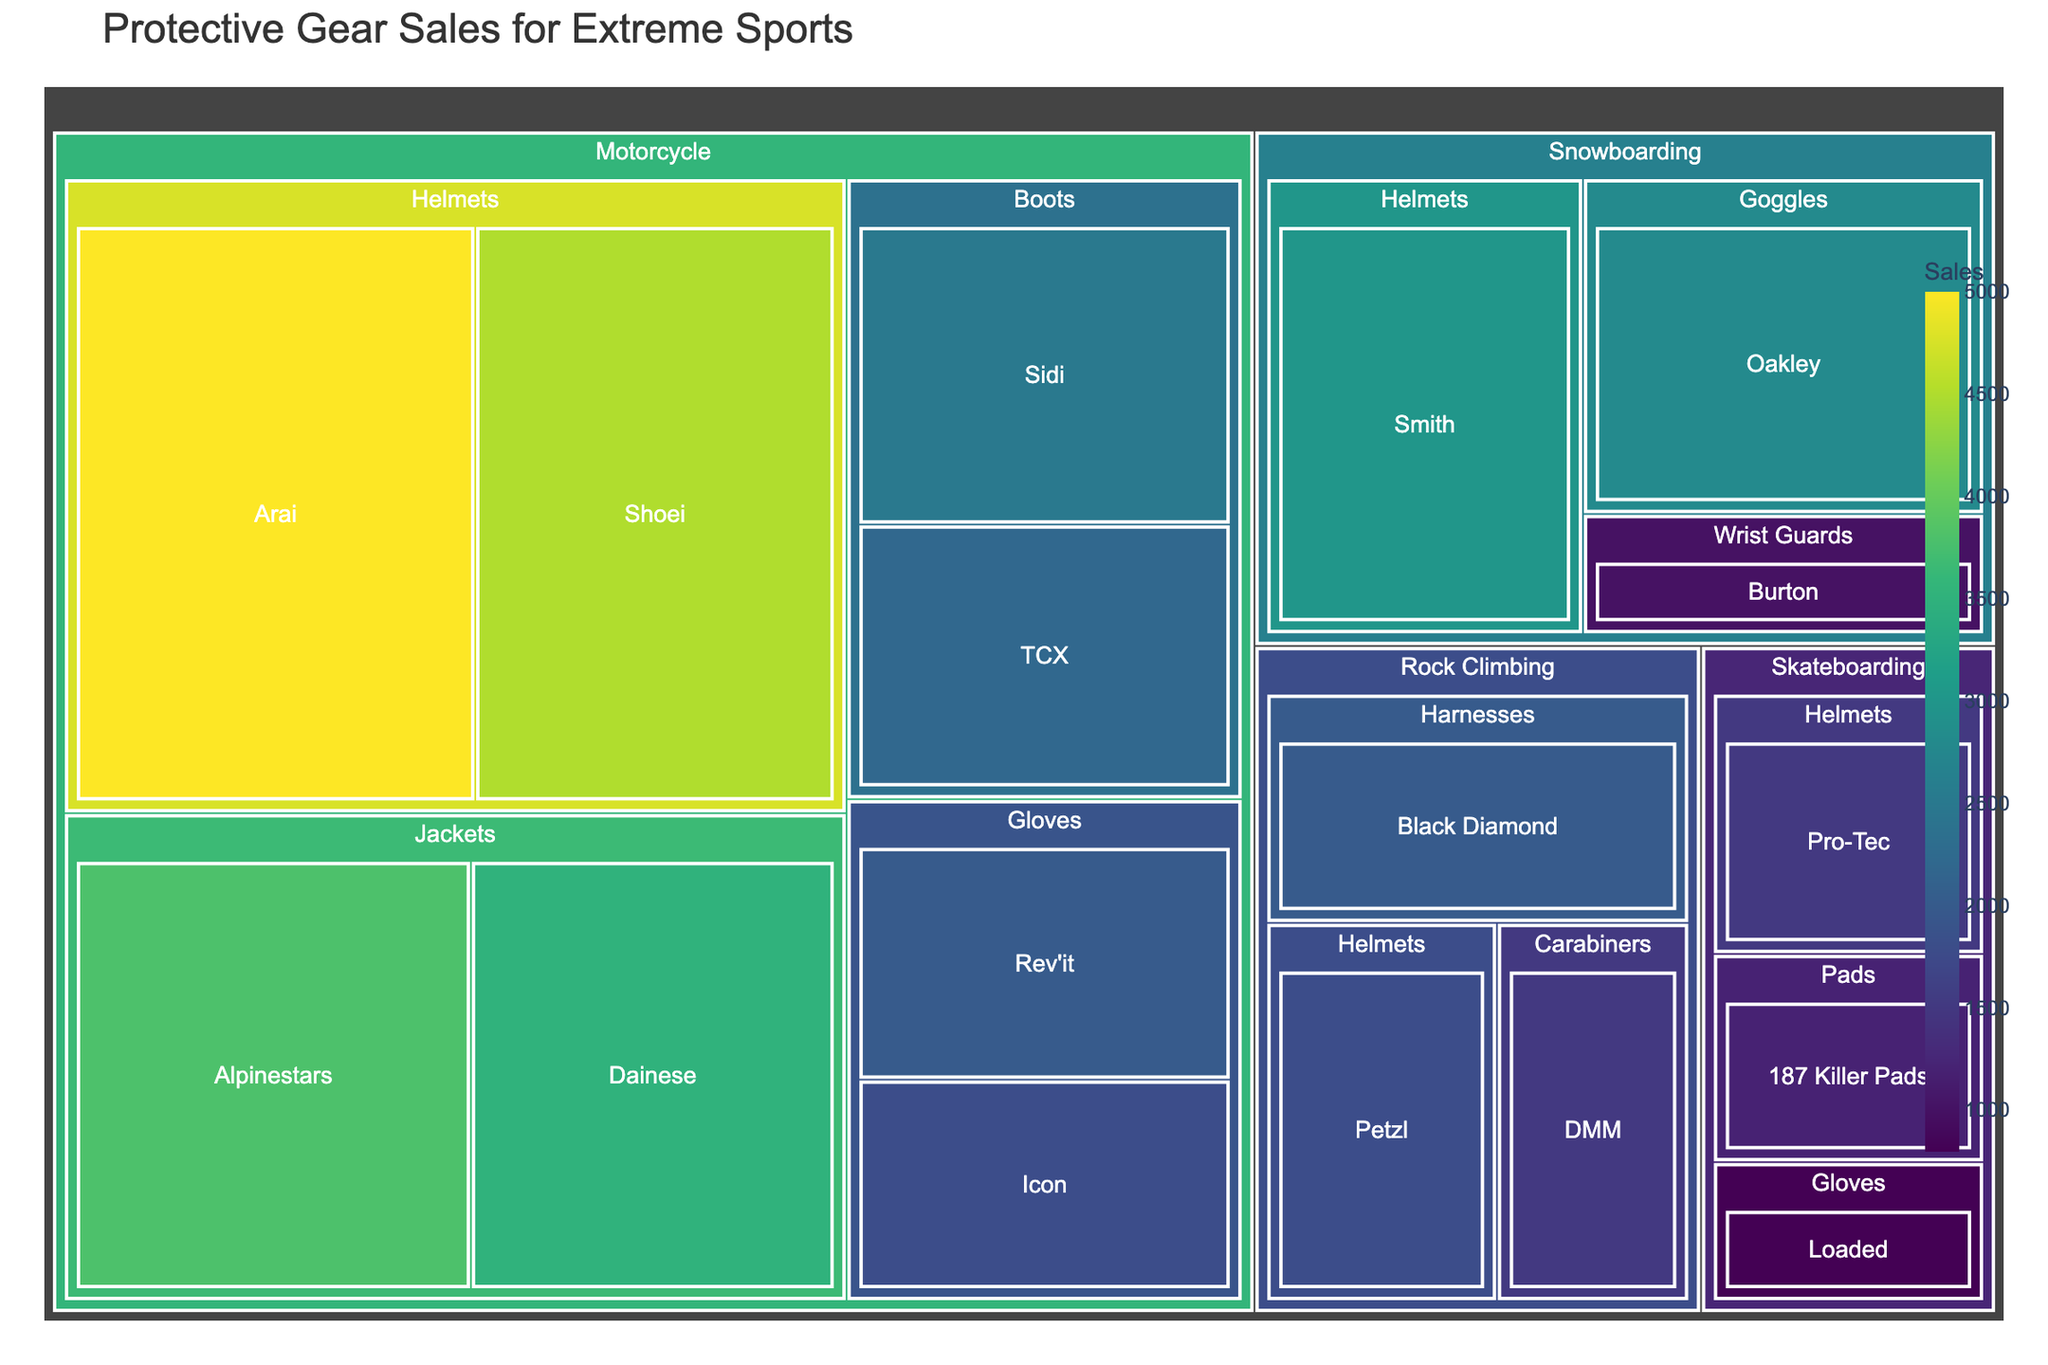What's the title of the treemap figure? The title is usually located at the top of the figure. In this case, it reads 'Protective Gear Sales for Extreme Sports'
Answer: Protective Gear Sales for Extreme Sports Which category has the highest total sales? The treemap visualizes sales by the size of the rectangles. The largest area indicates the category with the highest sales. Motorcycle has the largest area.
Answer: Motorcycle What are the total sales for all Helmet brands combined under the Motorcycle category? Add the sales from Arai and Shoei under the Motorcycle category: 5000 (Arai) + 4500 (Shoei) = 9500
Answer: 9500 Which brand has higher sales, Smith or Oakley? Compare the sales figures for Smith and Oakley. Smith has 3000 and Oakley has 2800. Smith has higher sales.
Answer: Smith What is the percentage of sales from Alpinestars out of the total jacket sales under the Motorcycle category? Calculate the total jacket sales: 3800 (Alpinestars) + 3500 (Dainese) = 7300. Then find the percentage: (3800 / 7300) * 100 = 52.05%
Answer: 52.05% How do the total sales figures for Helmets under the Snowboarding and Rock Climbing categories compare? Add up the sales figures for Helmets under both categories. Snowboarding Helmets: 3000 (Smith), Rock Climbing Helmets: 1800 (Petzl). So, 3000 is greater than 1800.
Answer: Snowboarding Helmets are higher What's the difference in sales between the highest and lowest selling equipment in the Skateboarding category? Identify the highest and lowest sales within Skateboarding. Highest: Helmets (1500), Lowest: Gloves (800). The difference is 1500 - 800 = 700
Answer: 700 Which Sport category has the fewest sales, and which equipment contributes to it? Identify the smallest area in the treemap, which represents the category with the fewest sales. Rock Climbing appears to be the smallest. The category contributing to it is Carabiners from DMM with 1500 sales.
Answer: Rock Climbing, Carabiners What is the average sales figure for equipment under the Motorcycle category? Sum the sales figures for all Motorcycle equipment and divide by the number of equipment types. Total Motorcycle sales: 5000 + 4500 + 3800 + 3500 + 2000 + 1800 + 2500 + 2200 = 25300, Number of types: 8. Average = 25300 / 8 = 3162.5
Answer: 3162.5 Which category has more uniform sales distribution between its equipment, Snowboarding or Rock Climbing? Compare the sales figures for each equipment type in both categories. Snowboarding: Helmets (3000), Goggles (2800), Wrist Guards (1000). Rock Climbing: Harnesses (2000), Helmets (1800), Carabiners (1500). Snowboarding’s numbers (ranging from 2800 to 1000) are more spread out compared to Rock Climbing’s numbers (2000 to 1500).
Answer: Rock Climbing 